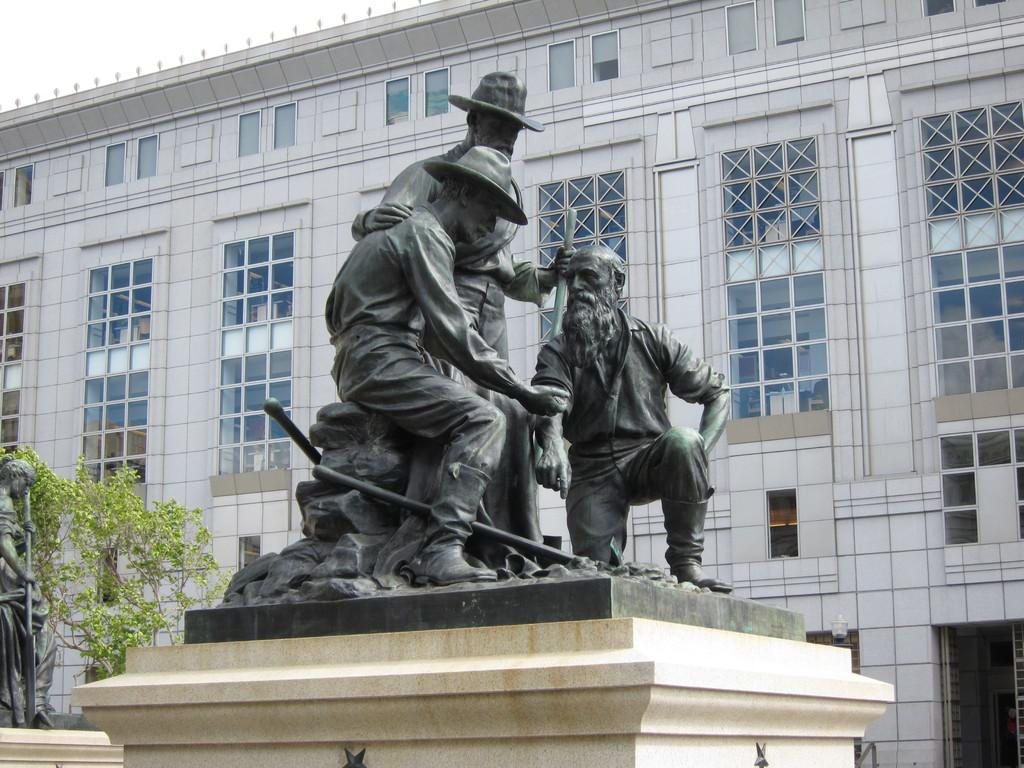What type of structure is in the image? There is a building in the image. What feature can be observed on the building? The building has glass windows. What objects are visible in front of the building? There are scepters visible in front of the building. How much lettuce is needed to cover the building in the image? There is no lettuce present in the image, so it cannot be determined how much would be needed to cover the building. 